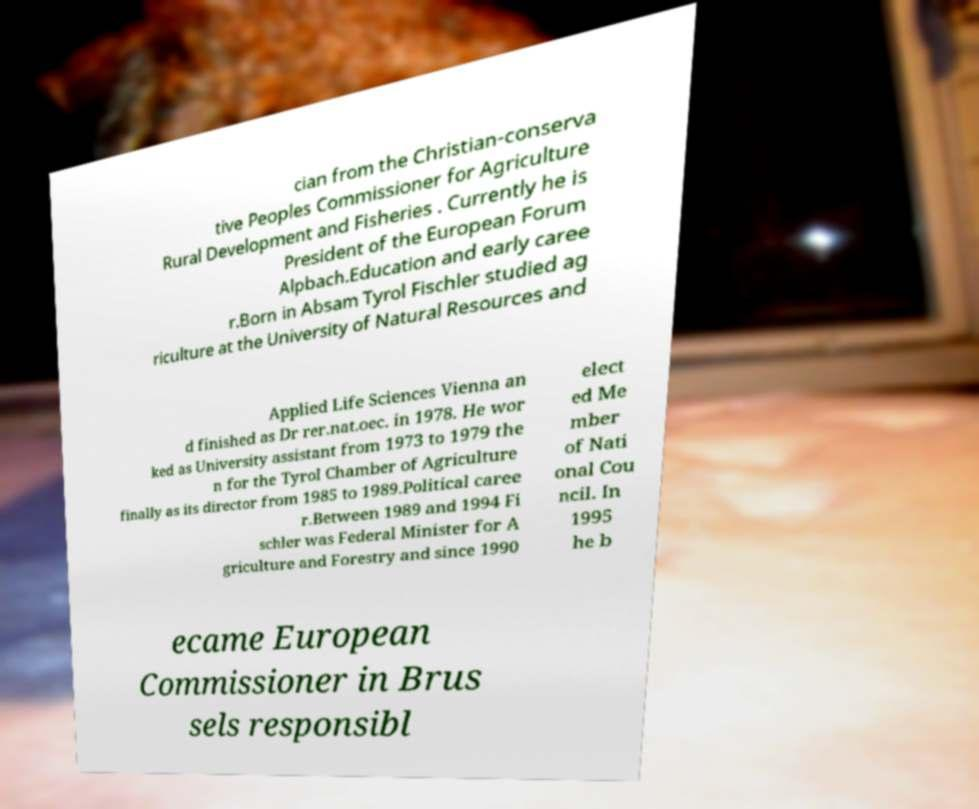I need the written content from this picture converted into text. Can you do that? cian from the Christian-conserva tive Peoples Commissioner for Agriculture Rural Development and Fisheries . Currently he is President of the European Forum Alpbach.Education and early caree r.Born in Absam Tyrol Fischler studied ag riculture at the University of Natural Resources and Applied Life Sciences Vienna an d finished as Dr rer.nat.oec. in 1978. He wor ked as University assistant from 1973 to 1979 the n for the Tyrol Chamber of Agriculture finally as its director from 1985 to 1989.Political caree r.Between 1989 and 1994 Fi schler was Federal Minister for A griculture and Forestry and since 1990 elect ed Me mber of Nati onal Cou ncil. In 1995 he b ecame European Commissioner in Brus sels responsibl 